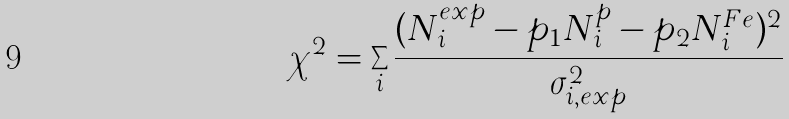<formula> <loc_0><loc_0><loc_500><loc_500>\chi ^ { 2 } = \sum _ { i } { \frac { ( N ^ { e x p } _ { i } - p _ { 1 } N ^ { p } _ { i } - p _ { 2 } N ^ { F e } _ { i } ) ^ { 2 } } { \sigma _ { i , e x p } ^ { 2 } } }</formula> 